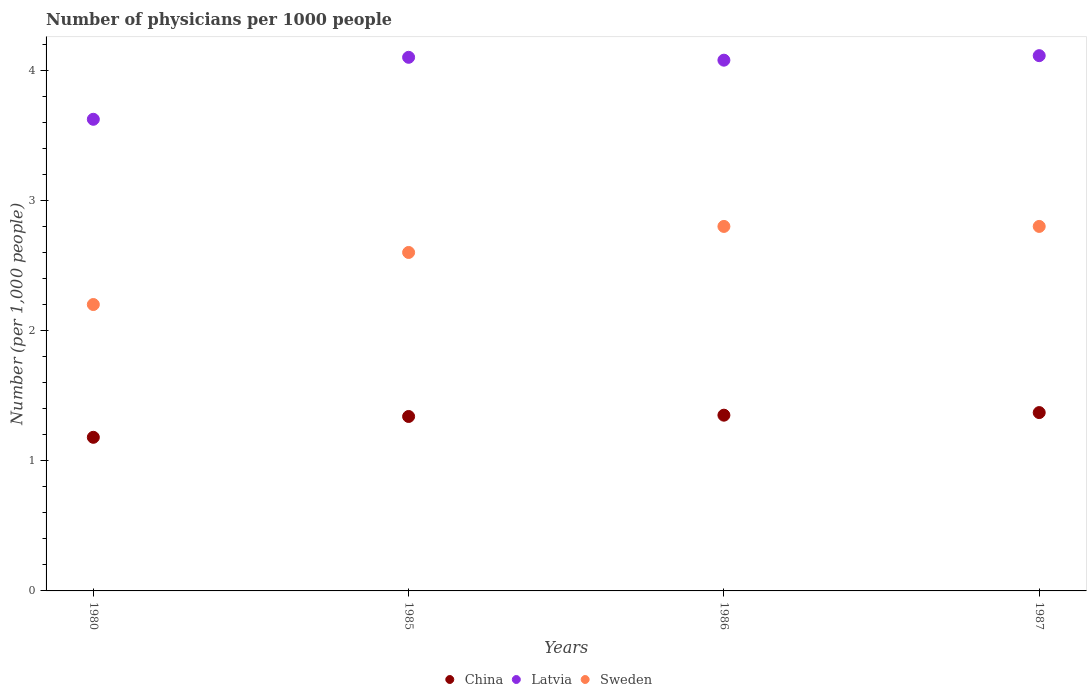How many different coloured dotlines are there?
Ensure brevity in your answer.  3. Across all years, what is the maximum number of physicians in Latvia?
Provide a short and direct response. 4.11. Across all years, what is the minimum number of physicians in Latvia?
Your answer should be compact. 3.62. What is the total number of physicians in Latvia in the graph?
Provide a short and direct response. 15.91. What is the difference between the number of physicians in Latvia in 1985 and that in 1986?
Your response must be concise. 0.02. What is the difference between the number of physicians in Latvia in 1986 and the number of physicians in Sweden in 1987?
Your answer should be very brief. 1.28. What is the average number of physicians in Latvia per year?
Offer a terse response. 3.98. In the year 1986, what is the difference between the number of physicians in Sweden and number of physicians in China?
Offer a terse response. 1.45. What is the ratio of the number of physicians in Sweden in 1985 to that in 1987?
Your answer should be compact. 0.93. Is the number of physicians in Sweden in 1986 less than that in 1987?
Your answer should be very brief. No. What is the difference between the highest and the second highest number of physicians in Latvia?
Your answer should be compact. 0.01. What is the difference between the highest and the lowest number of physicians in Sweden?
Give a very brief answer. 0.6. In how many years, is the number of physicians in Sweden greater than the average number of physicians in Sweden taken over all years?
Your answer should be compact. 2. Is the sum of the number of physicians in China in 1980 and 1987 greater than the maximum number of physicians in Sweden across all years?
Keep it short and to the point. No. Does the number of physicians in Sweden monotonically increase over the years?
Keep it short and to the point. No. Is the number of physicians in Latvia strictly greater than the number of physicians in Sweden over the years?
Offer a very short reply. Yes. Is the number of physicians in China strictly less than the number of physicians in Latvia over the years?
Your response must be concise. Yes. How many years are there in the graph?
Your answer should be compact. 4. Are the values on the major ticks of Y-axis written in scientific E-notation?
Provide a succinct answer. No. Does the graph contain grids?
Your answer should be very brief. No. What is the title of the graph?
Give a very brief answer. Number of physicians per 1000 people. What is the label or title of the X-axis?
Ensure brevity in your answer.  Years. What is the label or title of the Y-axis?
Keep it short and to the point. Number (per 1,0 people). What is the Number (per 1,000 people) of China in 1980?
Offer a terse response. 1.18. What is the Number (per 1,000 people) in Latvia in 1980?
Ensure brevity in your answer.  3.62. What is the Number (per 1,000 people) in Sweden in 1980?
Offer a very short reply. 2.2. What is the Number (per 1,000 people) in China in 1985?
Offer a terse response. 1.34. What is the Number (per 1,000 people) of Latvia in 1985?
Your response must be concise. 4.1. What is the Number (per 1,000 people) of Sweden in 1985?
Offer a very short reply. 2.6. What is the Number (per 1,000 people) of China in 1986?
Your answer should be compact. 1.35. What is the Number (per 1,000 people) of Latvia in 1986?
Offer a very short reply. 4.08. What is the Number (per 1,000 people) in China in 1987?
Make the answer very short. 1.37. What is the Number (per 1,000 people) in Latvia in 1987?
Your answer should be very brief. 4.11. What is the Number (per 1,000 people) of Sweden in 1987?
Your response must be concise. 2.8. Across all years, what is the maximum Number (per 1,000 people) of China?
Give a very brief answer. 1.37. Across all years, what is the maximum Number (per 1,000 people) of Latvia?
Your answer should be compact. 4.11. Across all years, what is the minimum Number (per 1,000 people) of China?
Give a very brief answer. 1.18. Across all years, what is the minimum Number (per 1,000 people) in Latvia?
Keep it short and to the point. 3.62. What is the total Number (per 1,000 people) of China in the graph?
Provide a short and direct response. 5.24. What is the total Number (per 1,000 people) in Latvia in the graph?
Your answer should be very brief. 15.91. What is the total Number (per 1,000 people) in Sweden in the graph?
Provide a succinct answer. 10.4. What is the difference between the Number (per 1,000 people) of China in 1980 and that in 1985?
Your answer should be very brief. -0.16. What is the difference between the Number (per 1,000 people) of Latvia in 1980 and that in 1985?
Provide a short and direct response. -0.48. What is the difference between the Number (per 1,000 people) in China in 1980 and that in 1986?
Provide a short and direct response. -0.17. What is the difference between the Number (per 1,000 people) in Latvia in 1980 and that in 1986?
Keep it short and to the point. -0.45. What is the difference between the Number (per 1,000 people) of Sweden in 1980 and that in 1986?
Provide a succinct answer. -0.6. What is the difference between the Number (per 1,000 people) in China in 1980 and that in 1987?
Give a very brief answer. -0.19. What is the difference between the Number (per 1,000 people) in Latvia in 1980 and that in 1987?
Give a very brief answer. -0.49. What is the difference between the Number (per 1,000 people) in Sweden in 1980 and that in 1987?
Your answer should be compact. -0.6. What is the difference between the Number (per 1,000 people) of China in 1985 and that in 1986?
Your answer should be very brief. -0.01. What is the difference between the Number (per 1,000 people) in Latvia in 1985 and that in 1986?
Keep it short and to the point. 0.02. What is the difference between the Number (per 1,000 people) in Sweden in 1985 and that in 1986?
Keep it short and to the point. -0.2. What is the difference between the Number (per 1,000 people) of China in 1985 and that in 1987?
Keep it short and to the point. -0.03. What is the difference between the Number (per 1,000 people) in Latvia in 1985 and that in 1987?
Offer a terse response. -0.01. What is the difference between the Number (per 1,000 people) of Sweden in 1985 and that in 1987?
Give a very brief answer. -0.2. What is the difference between the Number (per 1,000 people) in China in 1986 and that in 1987?
Ensure brevity in your answer.  -0.02. What is the difference between the Number (per 1,000 people) of Latvia in 1986 and that in 1987?
Your answer should be very brief. -0.03. What is the difference between the Number (per 1,000 people) of Sweden in 1986 and that in 1987?
Your answer should be very brief. 0. What is the difference between the Number (per 1,000 people) of China in 1980 and the Number (per 1,000 people) of Latvia in 1985?
Your answer should be compact. -2.92. What is the difference between the Number (per 1,000 people) of China in 1980 and the Number (per 1,000 people) of Sweden in 1985?
Your answer should be compact. -1.42. What is the difference between the Number (per 1,000 people) of China in 1980 and the Number (per 1,000 people) of Latvia in 1986?
Your answer should be very brief. -2.9. What is the difference between the Number (per 1,000 people) in China in 1980 and the Number (per 1,000 people) in Sweden in 1986?
Offer a very short reply. -1.62. What is the difference between the Number (per 1,000 people) in Latvia in 1980 and the Number (per 1,000 people) in Sweden in 1986?
Give a very brief answer. 0.82. What is the difference between the Number (per 1,000 people) in China in 1980 and the Number (per 1,000 people) in Latvia in 1987?
Give a very brief answer. -2.93. What is the difference between the Number (per 1,000 people) in China in 1980 and the Number (per 1,000 people) in Sweden in 1987?
Ensure brevity in your answer.  -1.62. What is the difference between the Number (per 1,000 people) of Latvia in 1980 and the Number (per 1,000 people) of Sweden in 1987?
Your answer should be compact. 0.82. What is the difference between the Number (per 1,000 people) of China in 1985 and the Number (per 1,000 people) of Latvia in 1986?
Ensure brevity in your answer.  -2.74. What is the difference between the Number (per 1,000 people) in China in 1985 and the Number (per 1,000 people) in Sweden in 1986?
Your answer should be compact. -1.46. What is the difference between the Number (per 1,000 people) in Latvia in 1985 and the Number (per 1,000 people) in Sweden in 1986?
Keep it short and to the point. 1.3. What is the difference between the Number (per 1,000 people) of China in 1985 and the Number (per 1,000 people) of Latvia in 1987?
Your response must be concise. -2.77. What is the difference between the Number (per 1,000 people) of China in 1985 and the Number (per 1,000 people) of Sweden in 1987?
Provide a short and direct response. -1.46. What is the difference between the Number (per 1,000 people) of Latvia in 1985 and the Number (per 1,000 people) of Sweden in 1987?
Make the answer very short. 1.3. What is the difference between the Number (per 1,000 people) in China in 1986 and the Number (per 1,000 people) in Latvia in 1987?
Offer a very short reply. -2.76. What is the difference between the Number (per 1,000 people) of China in 1986 and the Number (per 1,000 people) of Sweden in 1987?
Ensure brevity in your answer.  -1.45. What is the difference between the Number (per 1,000 people) of Latvia in 1986 and the Number (per 1,000 people) of Sweden in 1987?
Provide a short and direct response. 1.28. What is the average Number (per 1,000 people) in China per year?
Provide a short and direct response. 1.31. What is the average Number (per 1,000 people) in Latvia per year?
Give a very brief answer. 3.98. What is the average Number (per 1,000 people) of Sweden per year?
Your response must be concise. 2.6. In the year 1980, what is the difference between the Number (per 1,000 people) of China and Number (per 1,000 people) of Latvia?
Ensure brevity in your answer.  -2.44. In the year 1980, what is the difference between the Number (per 1,000 people) in China and Number (per 1,000 people) in Sweden?
Your answer should be compact. -1.02. In the year 1980, what is the difference between the Number (per 1,000 people) of Latvia and Number (per 1,000 people) of Sweden?
Give a very brief answer. 1.42. In the year 1985, what is the difference between the Number (per 1,000 people) in China and Number (per 1,000 people) in Latvia?
Ensure brevity in your answer.  -2.76. In the year 1985, what is the difference between the Number (per 1,000 people) in China and Number (per 1,000 people) in Sweden?
Offer a very short reply. -1.26. In the year 1985, what is the difference between the Number (per 1,000 people) in Latvia and Number (per 1,000 people) in Sweden?
Your response must be concise. 1.5. In the year 1986, what is the difference between the Number (per 1,000 people) of China and Number (per 1,000 people) of Latvia?
Give a very brief answer. -2.73. In the year 1986, what is the difference between the Number (per 1,000 people) in China and Number (per 1,000 people) in Sweden?
Your answer should be compact. -1.45. In the year 1986, what is the difference between the Number (per 1,000 people) of Latvia and Number (per 1,000 people) of Sweden?
Offer a very short reply. 1.28. In the year 1987, what is the difference between the Number (per 1,000 people) of China and Number (per 1,000 people) of Latvia?
Provide a short and direct response. -2.74. In the year 1987, what is the difference between the Number (per 1,000 people) of China and Number (per 1,000 people) of Sweden?
Your answer should be very brief. -1.43. In the year 1987, what is the difference between the Number (per 1,000 people) of Latvia and Number (per 1,000 people) of Sweden?
Offer a terse response. 1.31. What is the ratio of the Number (per 1,000 people) in China in 1980 to that in 1985?
Offer a very short reply. 0.88. What is the ratio of the Number (per 1,000 people) of Latvia in 1980 to that in 1985?
Keep it short and to the point. 0.88. What is the ratio of the Number (per 1,000 people) in Sweden in 1980 to that in 1985?
Give a very brief answer. 0.85. What is the ratio of the Number (per 1,000 people) in China in 1980 to that in 1986?
Provide a succinct answer. 0.87. What is the ratio of the Number (per 1,000 people) in Latvia in 1980 to that in 1986?
Make the answer very short. 0.89. What is the ratio of the Number (per 1,000 people) of Sweden in 1980 to that in 1986?
Keep it short and to the point. 0.79. What is the ratio of the Number (per 1,000 people) in China in 1980 to that in 1987?
Give a very brief answer. 0.86. What is the ratio of the Number (per 1,000 people) of Latvia in 1980 to that in 1987?
Keep it short and to the point. 0.88. What is the ratio of the Number (per 1,000 people) in Sweden in 1980 to that in 1987?
Ensure brevity in your answer.  0.79. What is the ratio of the Number (per 1,000 people) of Latvia in 1985 to that in 1986?
Offer a very short reply. 1.01. What is the ratio of the Number (per 1,000 people) in Sweden in 1985 to that in 1986?
Give a very brief answer. 0.93. What is the ratio of the Number (per 1,000 people) of China in 1985 to that in 1987?
Make the answer very short. 0.98. What is the ratio of the Number (per 1,000 people) of Latvia in 1985 to that in 1987?
Keep it short and to the point. 1. What is the ratio of the Number (per 1,000 people) of China in 1986 to that in 1987?
Offer a terse response. 0.99. What is the ratio of the Number (per 1,000 people) in Latvia in 1986 to that in 1987?
Keep it short and to the point. 0.99. What is the difference between the highest and the second highest Number (per 1,000 people) in Latvia?
Your answer should be compact. 0.01. What is the difference between the highest and the lowest Number (per 1,000 people) of China?
Make the answer very short. 0.19. What is the difference between the highest and the lowest Number (per 1,000 people) in Latvia?
Give a very brief answer. 0.49. What is the difference between the highest and the lowest Number (per 1,000 people) in Sweden?
Provide a short and direct response. 0.6. 